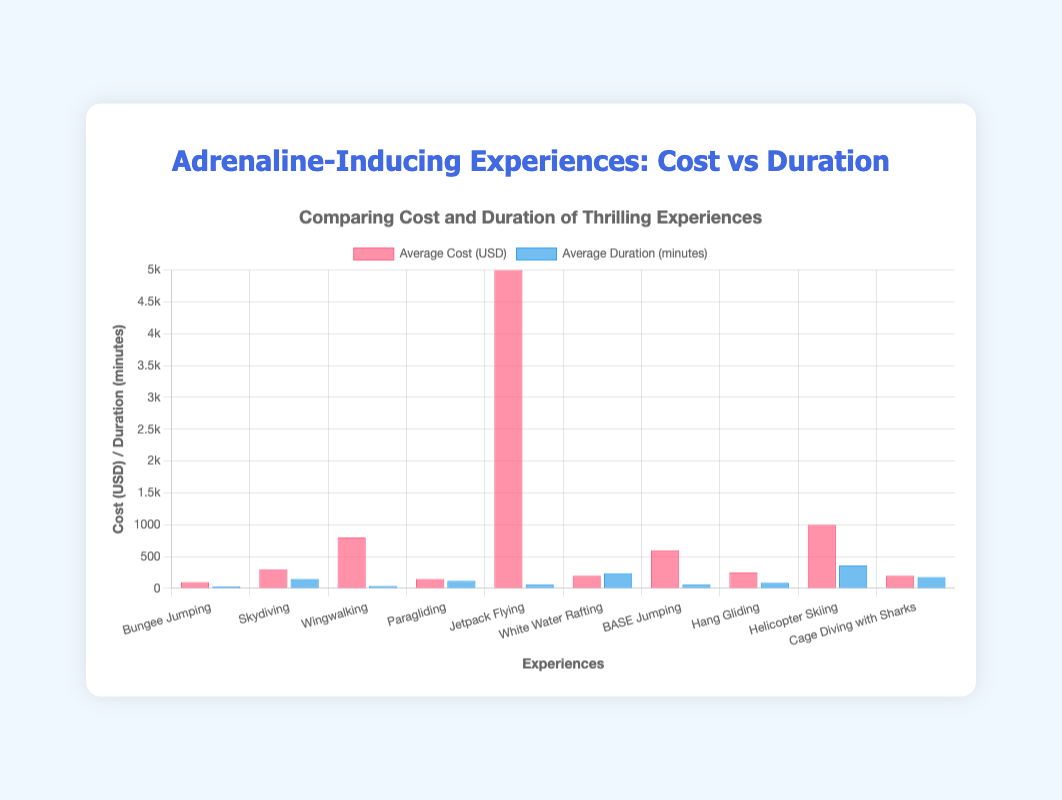Which experience has the highest average cost? From the bar chart, the tallest bar in the "Average Cost (USD)" dataset indicates the highest cost. Jetpack Flying has the tallest bar.
Answer: Jetpack Flying Which experience has the longest average duration? The tallest bar in the "Average Duration (minutes)" dataset represents the longest duration. Helicopter Skiing has the tallest bar for duration.
Answer: Helicopter Skiing What is the difference in cost between the most expensive and the least expensive experience? The most expensive experience is Jetpack Flying at 5000 USD, and the least expensive is Bungee Jumping at 100 USD. The difference is 5000 - 100 = 4900 USD.
Answer: 4900 USD Which experience has both the costs and durations lower than Wingwalking? Wingwalking has an average cost of 800 USD and duration of 40 minutes. The experiences with both lower cost and duration are Bungee Jumping (100 USD, 30 minutes), Paragliding (150 USD, 120 minutes - duration exceeds), and White Water Rafting (200 USD, 240 minutes - duration exceeds), BASE Jumping (600 USD, 60 minutes - duration exceeds), Hang Gliding (250 USD, 90 minutes - duration exceeds). Only Bungee Jumping satisfies both conditions.
Answer: Bungee Jumping Compare the average duration of Jetpack Flying with BASE Jumping. Which one lasts longer? The average duration of Jetpack Flying is 60 minutes, while BASE Jumping is also 60 minutes. They are equal in duration.
Answer: They are equal Which experiences have an average duration greater than 200 minutes? The experiences with bars taller than the 200-minute mark in the "Average Duration (minutes)" dataset are White Water Rafting (240 minutes), Cage Diving with Sharks (180 minutes - does not exceed), and Helicopter Skiing (360 minutes).
Answer: White Water Rafting and Helicopter Skiing What is the average cost and duration for Paragliding and Hang Gliding combined? Paragliding costs 150 USD with a duration of 120 minutes, and Hang Gliding costs 250 USD with a duration of 90 minutes. The average cost is (150 + 250) / 2 = 200 USD, and the average duration is (120 + 90) / 2 = 105 minutes.
Answer: 200 USD and 105 minutes How much more does Wingwalking cost than Skydiving? Wingwalking costs 800 USD while Skydiving costs 300 USD. The difference is 800 - 300 = 500 USD.
Answer: 500 USD Which experience has the lowest average duration? The shortest bar in the "Average Duration (minutes)" dataset indicates the lowest duration. Bungee Jumping has the shortest bar with an average duration of 30 minutes.
Answer: Bungee Jumping 